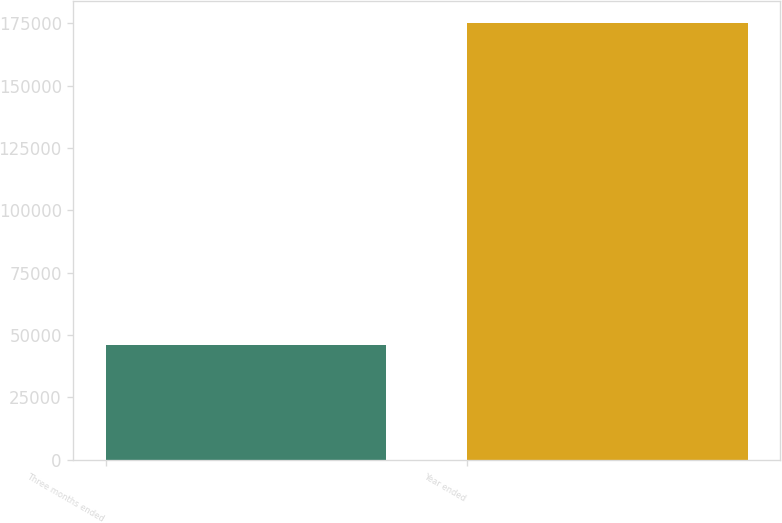Convert chart to OTSL. <chart><loc_0><loc_0><loc_500><loc_500><bar_chart><fcel>Three months ended<fcel>Year ended<nl><fcel>46121<fcel>175073<nl></chart> 